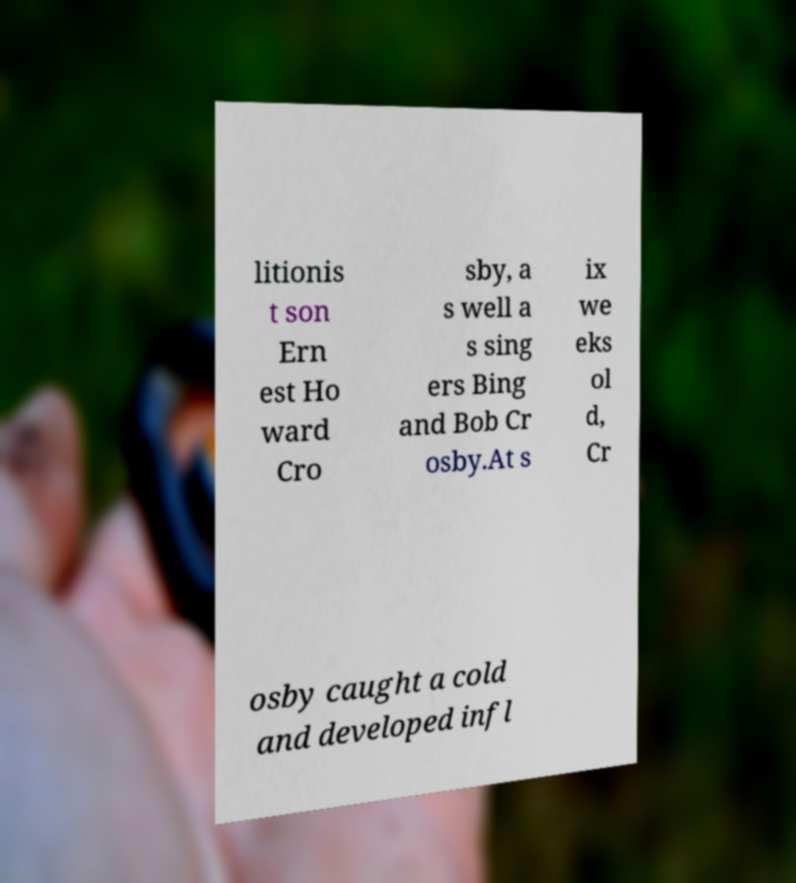Can you read and provide the text displayed in the image?This photo seems to have some interesting text. Can you extract and type it out for me? litionis t son Ern est Ho ward Cro sby, a s well a s sing ers Bing and Bob Cr osby.At s ix we eks ol d, Cr osby caught a cold and developed infl 